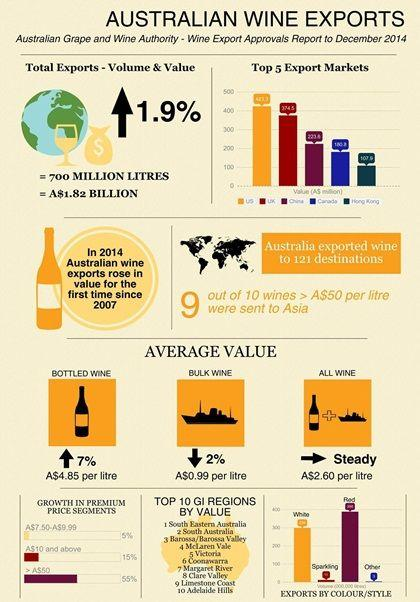Identify some key points in this picture. On average, bottled wine has experienced an increase in value. The average value of bulk wine has decreased. In 2014, the wine export increased compared to 2007. The value of total exports was A$1.82 billion. The increase in total exports was 1.9%. 